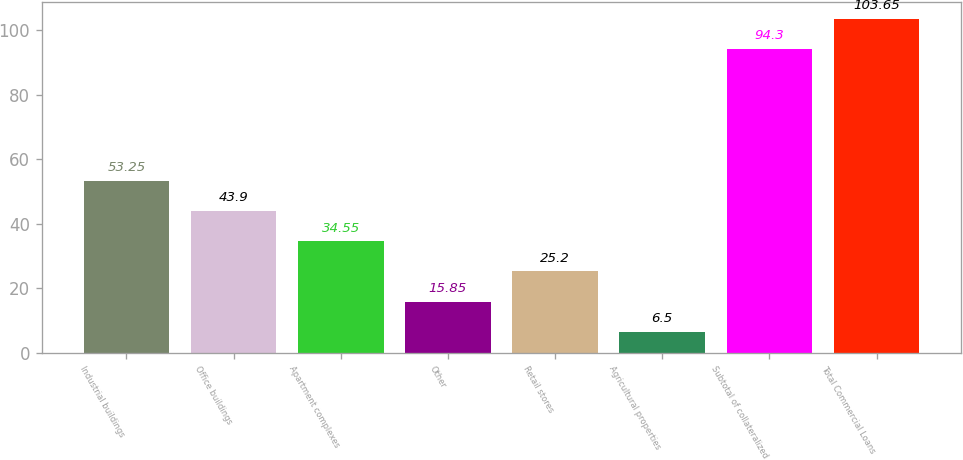Convert chart. <chart><loc_0><loc_0><loc_500><loc_500><bar_chart><fcel>Industrial buildings<fcel>Office buildings<fcel>Apartment complexes<fcel>Other<fcel>Retail stores<fcel>Agricultural properties<fcel>Subtotal of collateralized<fcel>Total Commercial Loans<nl><fcel>53.25<fcel>43.9<fcel>34.55<fcel>15.85<fcel>25.2<fcel>6.5<fcel>94.3<fcel>103.65<nl></chart> 